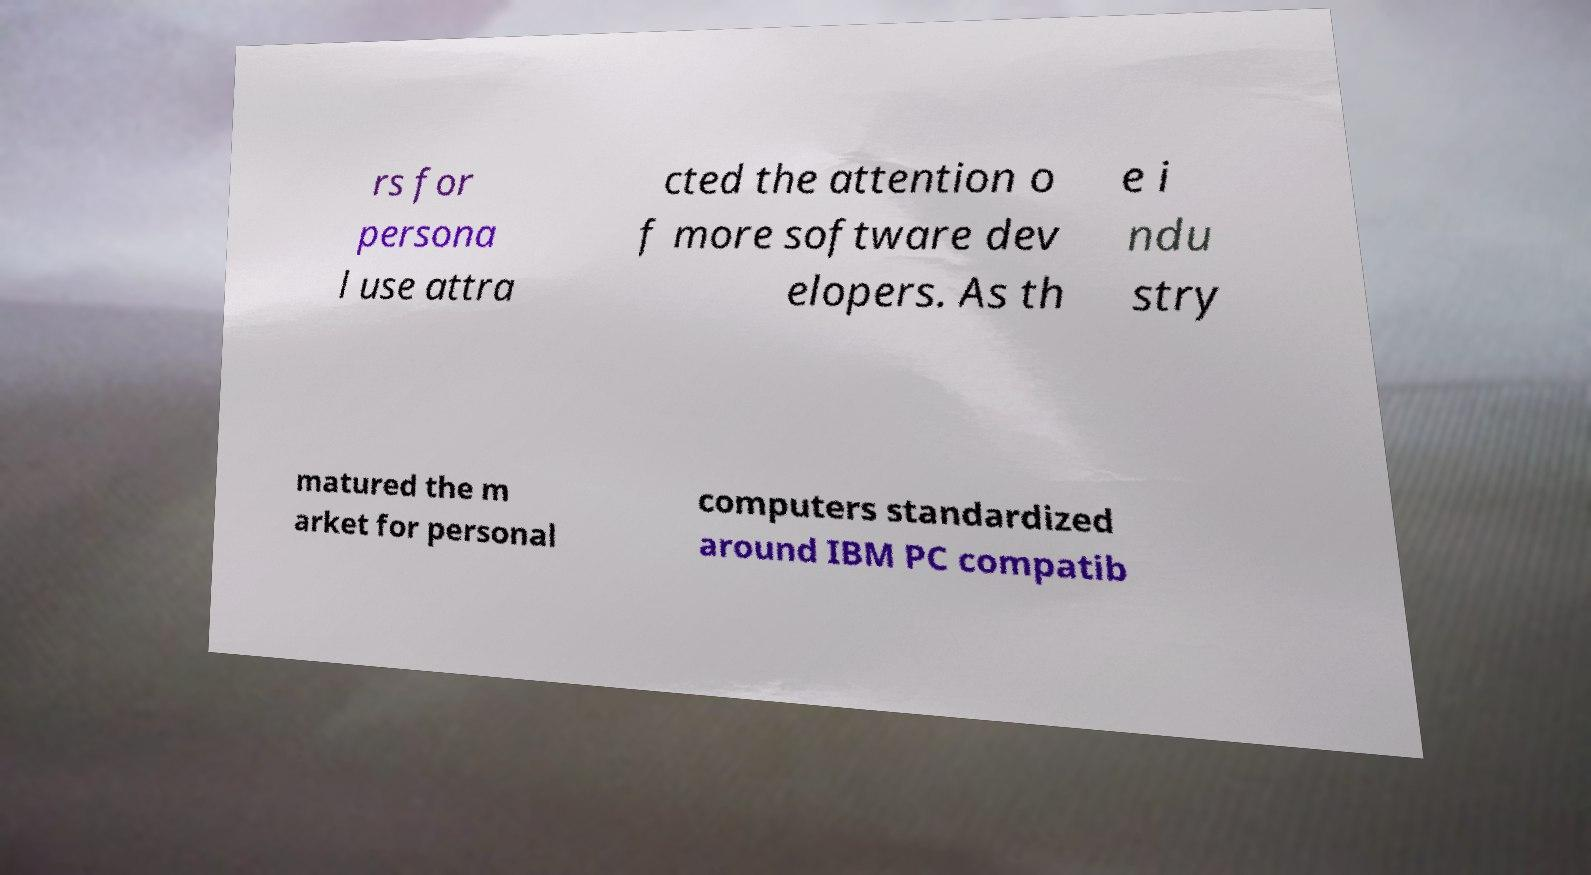For documentation purposes, I need the text within this image transcribed. Could you provide that? rs for persona l use attra cted the attention o f more software dev elopers. As th e i ndu stry matured the m arket for personal computers standardized around IBM PC compatib 